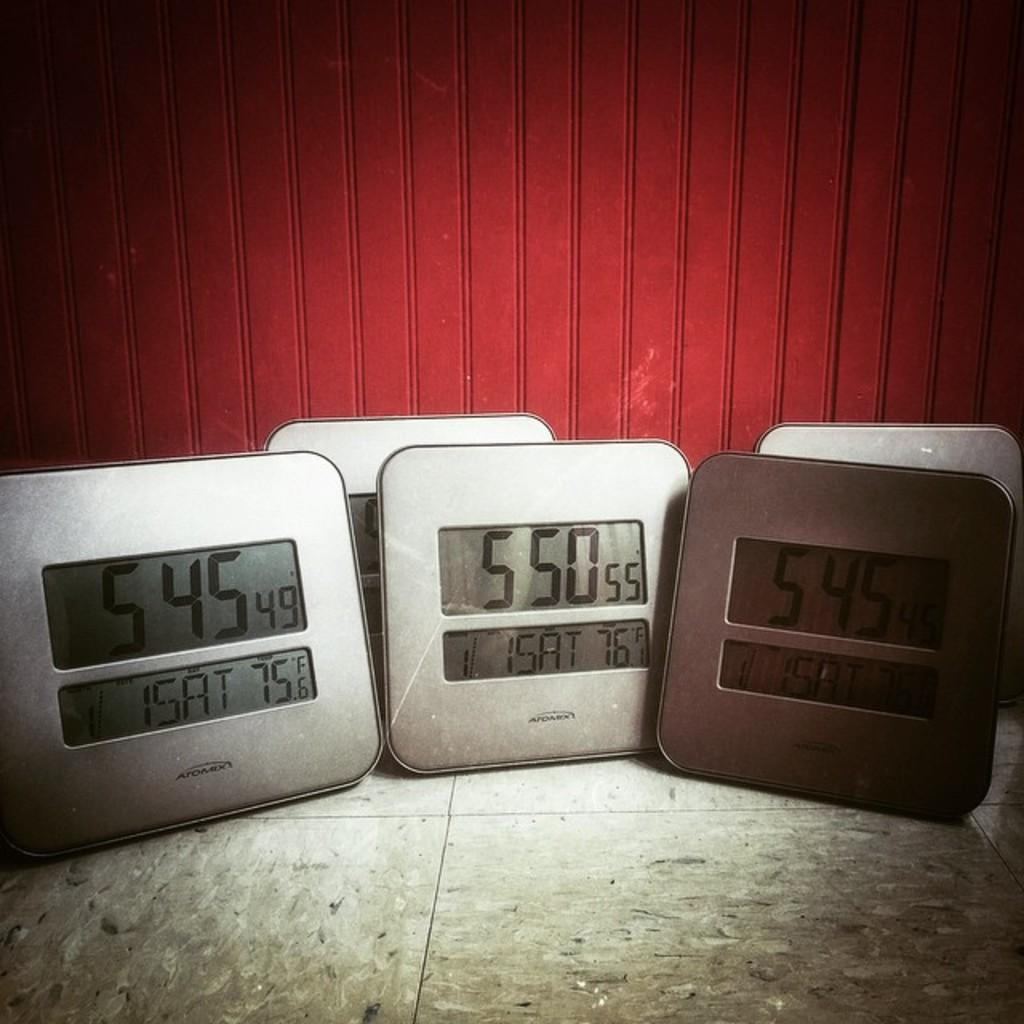Provide a one-sentence caption for the provided image. The clocks show two different times and to different temperatures in the the same room. 